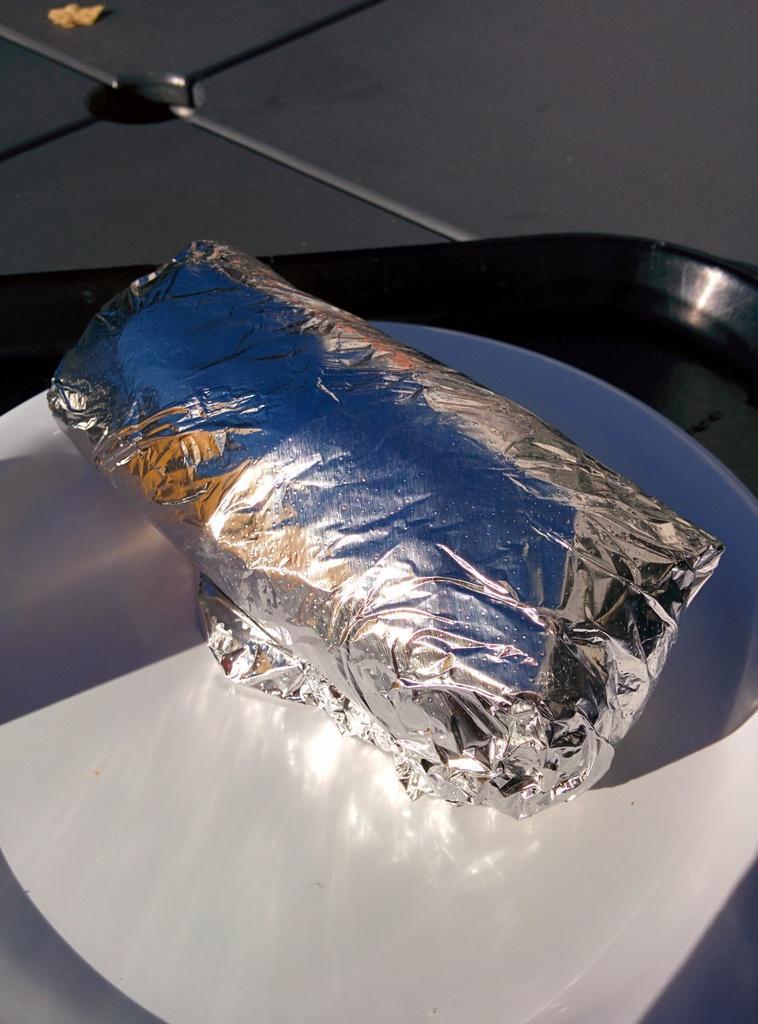How would you summarize this image in a sentence or two? Here we can see a silver paper with something in it is rolled and kept in a plate on a tray on a platform and at the top there is an object. 